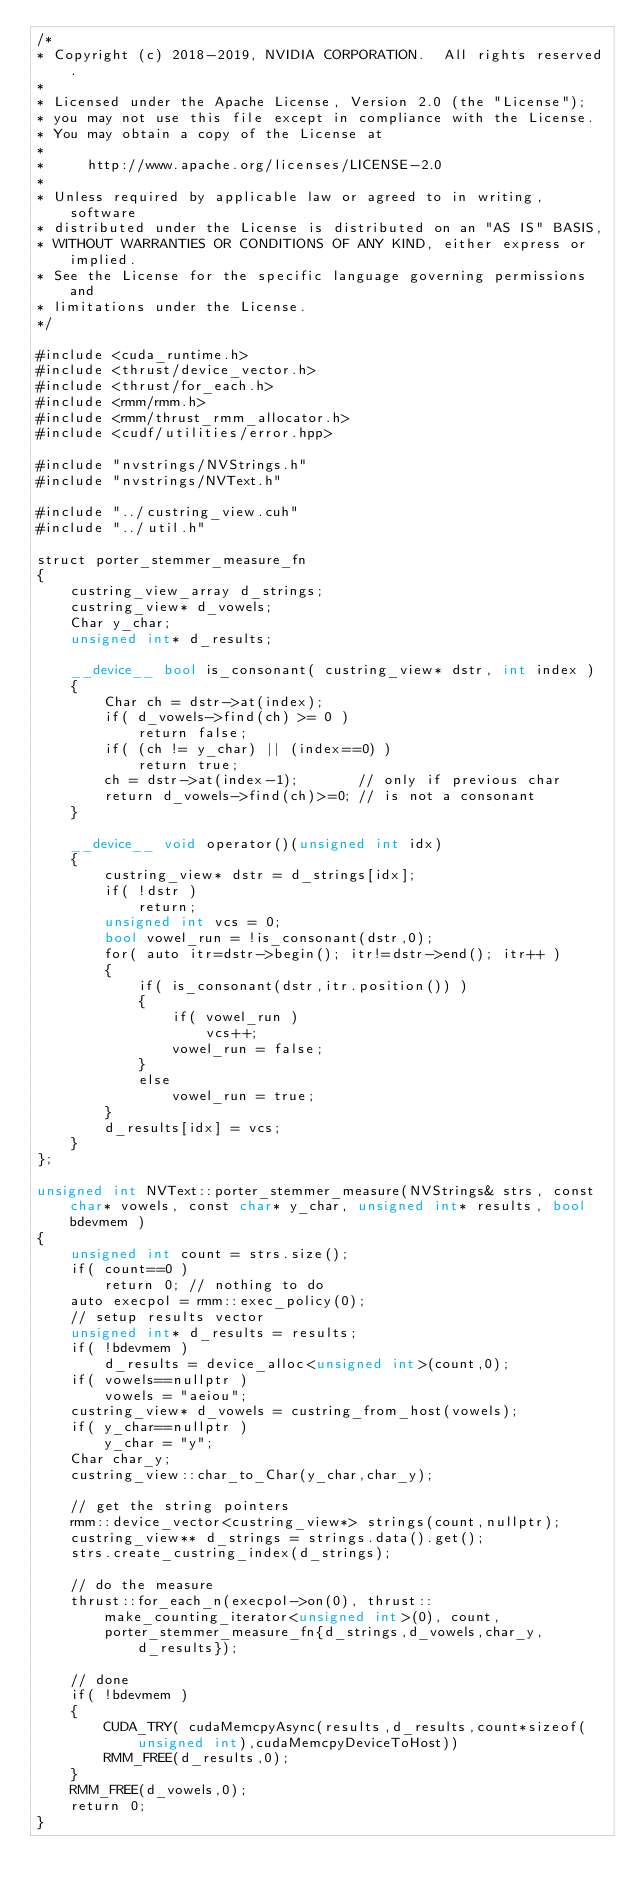Convert code to text. <code><loc_0><loc_0><loc_500><loc_500><_Cuda_>/*
* Copyright (c) 2018-2019, NVIDIA CORPORATION.  All rights reserved.
*
* Licensed under the Apache License, Version 2.0 (the "License");
* you may not use this file except in compliance with the License.
* You may obtain a copy of the License at
*
*     http://www.apache.org/licenses/LICENSE-2.0
*
* Unless required by applicable law or agreed to in writing, software
* distributed under the License is distributed on an "AS IS" BASIS,
* WITHOUT WARRANTIES OR CONDITIONS OF ANY KIND, either express or implied.
* See the License for the specific language governing permissions and
* limitations under the License.
*/

#include <cuda_runtime.h>
#include <thrust/device_vector.h>
#include <thrust/for_each.h>
#include <rmm/rmm.h>
#include <rmm/thrust_rmm_allocator.h>
#include <cudf/utilities/error.hpp>

#include "nvstrings/NVStrings.h"
#include "nvstrings/NVText.h"

#include "../custring_view.cuh"
#include "../util.h"

struct porter_stemmer_measure_fn
{
    custring_view_array d_strings;
    custring_view* d_vowels;
    Char y_char;
    unsigned int* d_results;

    __device__ bool is_consonant( custring_view* dstr, int index )
    {
        Char ch = dstr->at(index);
        if( d_vowels->find(ch) >= 0 )
            return false;
        if( (ch != y_char) || (index==0) )
            return true;
        ch = dstr->at(index-1);       // only if previous char
        return d_vowels->find(ch)>=0; // is not a consonant
    }

    __device__ void operator()(unsigned int idx)
    {
        custring_view* dstr = d_strings[idx];
        if( !dstr )
            return;
        unsigned int vcs = 0;
        bool vowel_run = !is_consonant(dstr,0);
        for( auto itr=dstr->begin(); itr!=dstr->end(); itr++ )
        {
            if( is_consonant(dstr,itr.position()) )
            {
                if( vowel_run )
                    vcs++;
                vowel_run = false;
            }
            else
                vowel_run = true;
        }
        d_results[idx] = vcs;
    }
};

unsigned int NVText::porter_stemmer_measure(NVStrings& strs, const char* vowels, const char* y_char, unsigned int* results, bool bdevmem )
{
    unsigned int count = strs.size();
    if( count==0 )
        return 0; // nothing to do
    auto execpol = rmm::exec_policy(0);
    // setup results vector
    unsigned int* d_results = results;
    if( !bdevmem )
        d_results = device_alloc<unsigned int>(count,0);
    if( vowels==nullptr )
        vowels = "aeiou";
    custring_view* d_vowels = custring_from_host(vowels);
    if( y_char==nullptr )
        y_char = "y";
    Char char_y;
    custring_view::char_to_Char(y_char,char_y);

    // get the string pointers
    rmm::device_vector<custring_view*> strings(count,nullptr);
    custring_view** d_strings = strings.data().get();
    strs.create_custring_index(d_strings);

    // do the measure
    thrust::for_each_n(execpol->on(0), thrust::make_counting_iterator<unsigned int>(0), count,
        porter_stemmer_measure_fn{d_strings,d_vowels,char_y,d_results});

    // done
    if( !bdevmem )
    {
        CUDA_TRY( cudaMemcpyAsync(results,d_results,count*sizeof(unsigned int),cudaMemcpyDeviceToHost))
        RMM_FREE(d_results,0);
    }
    RMM_FREE(d_vowels,0);
    return 0;
}</code> 